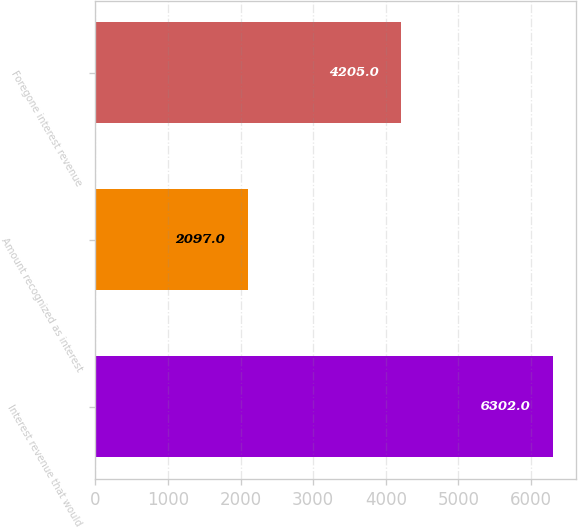Convert chart to OTSL. <chart><loc_0><loc_0><loc_500><loc_500><bar_chart><fcel>Interest revenue that would<fcel>Amount recognized as interest<fcel>Foregone interest revenue<nl><fcel>6302<fcel>2097<fcel>4205<nl></chart> 